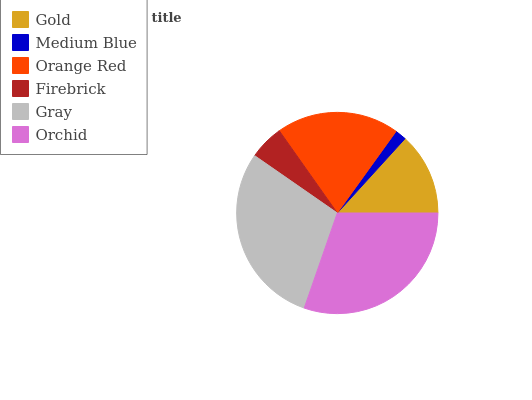Is Medium Blue the minimum?
Answer yes or no. Yes. Is Orchid the maximum?
Answer yes or no. Yes. Is Orange Red the minimum?
Answer yes or no. No. Is Orange Red the maximum?
Answer yes or no. No. Is Orange Red greater than Medium Blue?
Answer yes or no. Yes. Is Medium Blue less than Orange Red?
Answer yes or no. Yes. Is Medium Blue greater than Orange Red?
Answer yes or no. No. Is Orange Red less than Medium Blue?
Answer yes or no. No. Is Orange Red the high median?
Answer yes or no. Yes. Is Gold the low median?
Answer yes or no. Yes. Is Gold the high median?
Answer yes or no. No. Is Firebrick the low median?
Answer yes or no. No. 